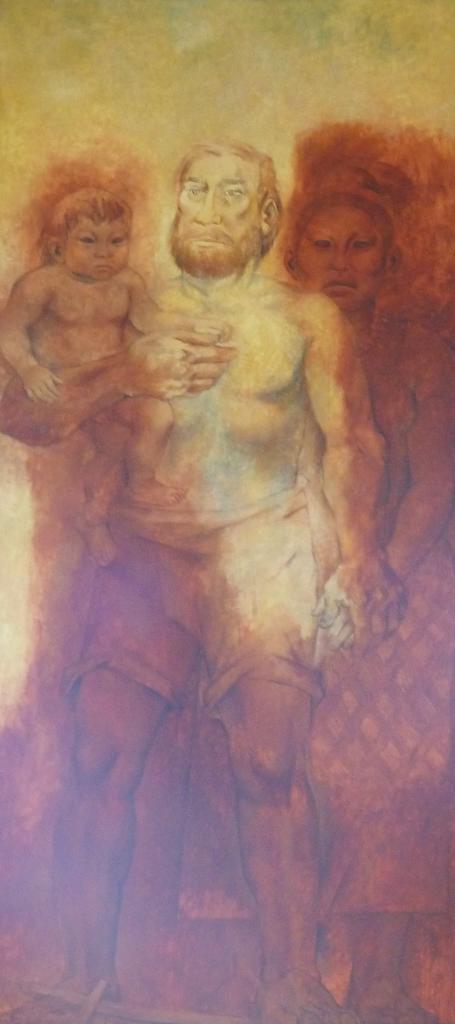In one or two sentences, can you explain what this image depicts? In this image we can see depictions of persons. 